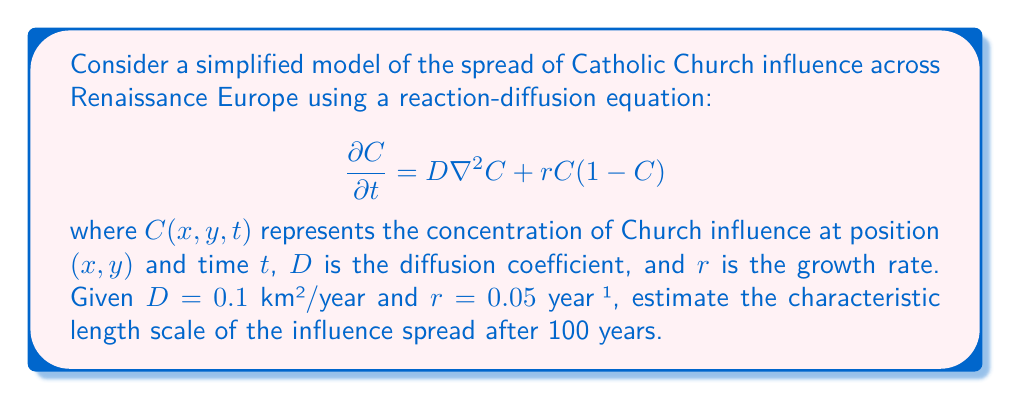Could you help me with this problem? To solve this problem, we'll follow these steps:

1) The characteristic length scale in a reaction-diffusion system is given by the formula:

   $$L = \sqrt{\frac{D}{r}}$$

2) We're given:
   $D = 0.1$ km²/year
   $r = 0.05$ year⁻¹

3) Substituting these values into the formula:

   $$L = \sqrt{\frac{0.1}{0.05}}$$

4) Simplifying:
   
   $$L = \sqrt{2}$$

5) This gives us the characteristic length scale in kilometers. However, we need to consider the time frame of 100 years.

6) The spread of influence over time follows a $\sqrt{t}$ relationship. So after 100 years, the characteristic length scale would be:

   $$L_{100} = \sqrt{2} \cdot \sqrt{100} = 10\sqrt{2}$$

7) Therefore, the characteristic length scale of the Church's influence spread after 100 years is approximately 14.14 km.
Answer: $10\sqrt{2}$ km or approximately 14.14 km 